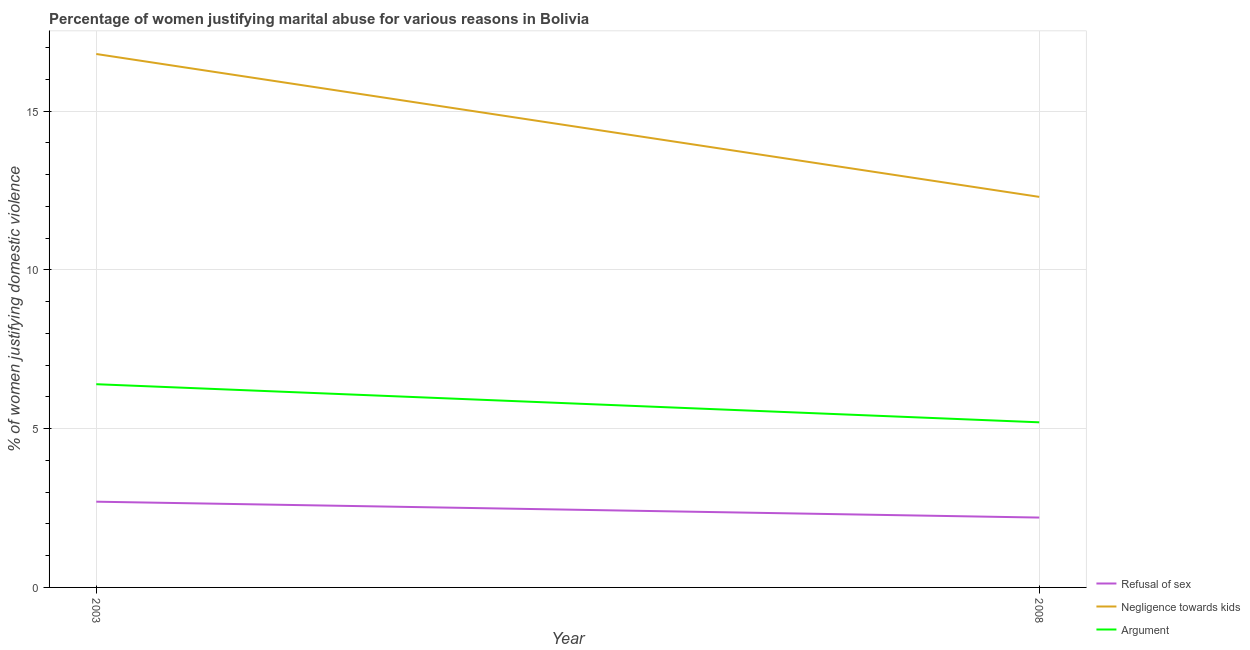Across all years, what is the minimum percentage of women justifying domestic violence due to negligence towards kids?
Give a very brief answer. 12.3. What is the total percentage of women justifying domestic violence due to arguments in the graph?
Your answer should be compact. 11.6. What is the difference between the percentage of women justifying domestic violence due to arguments in 2003 and that in 2008?
Offer a terse response. 1.2. What is the difference between the percentage of women justifying domestic violence due to refusal of sex in 2008 and the percentage of women justifying domestic violence due to negligence towards kids in 2003?
Offer a terse response. -14.6. What is the average percentage of women justifying domestic violence due to arguments per year?
Keep it short and to the point. 5.8. What is the ratio of the percentage of women justifying domestic violence due to refusal of sex in 2003 to that in 2008?
Provide a short and direct response. 1.23. Is the percentage of women justifying domestic violence due to negligence towards kids strictly greater than the percentage of women justifying domestic violence due to arguments over the years?
Offer a very short reply. Yes. How many years are there in the graph?
Your answer should be very brief. 2. What is the difference between two consecutive major ticks on the Y-axis?
Your response must be concise. 5. Where does the legend appear in the graph?
Your answer should be very brief. Bottom right. How are the legend labels stacked?
Give a very brief answer. Vertical. What is the title of the graph?
Give a very brief answer. Percentage of women justifying marital abuse for various reasons in Bolivia. Does "Refusal of sex" appear as one of the legend labels in the graph?
Your response must be concise. Yes. What is the label or title of the Y-axis?
Ensure brevity in your answer.  % of women justifying domestic violence. What is the % of women justifying domestic violence of Negligence towards kids in 2003?
Provide a succinct answer. 16.8. What is the % of women justifying domestic violence in Argument in 2003?
Give a very brief answer. 6.4. What is the % of women justifying domestic violence of Refusal of sex in 2008?
Ensure brevity in your answer.  2.2. What is the % of women justifying domestic violence in Argument in 2008?
Offer a terse response. 5.2. Across all years, what is the maximum % of women justifying domestic violence in Argument?
Provide a succinct answer. 6.4. What is the total % of women justifying domestic violence of Refusal of sex in the graph?
Make the answer very short. 4.9. What is the total % of women justifying domestic violence in Negligence towards kids in the graph?
Your answer should be very brief. 29.1. What is the difference between the % of women justifying domestic violence of Refusal of sex in 2003 and that in 2008?
Offer a very short reply. 0.5. What is the difference between the % of women justifying domestic violence of Negligence towards kids in 2003 and that in 2008?
Offer a terse response. 4.5. What is the difference between the % of women justifying domestic violence in Refusal of sex in 2003 and the % of women justifying domestic violence in Argument in 2008?
Ensure brevity in your answer.  -2.5. What is the difference between the % of women justifying domestic violence in Negligence towards kids in 2003 and the % of women justifying domestic violence in Argument in 2008?
Your answer should be very brief. 11.6. What is the average % of women justifying domestic violence in Refusal of sex per year?
Give a very brief answer. 2.45. What is the average % of women justifying domestic violence of Negligence towards kids per year?
Ensure brevity in your answer.  14.55. What is the average % of women justifying domestic violence in Argument per year?
Make the answer very short. 5.8. In the year 2003, what is the difference between the % of women justifying domestic violence in Refusal of sex and % of women justifying domestic violence in Negligence towards kids?
Make the answer very short. -14.1. In the year 2008, what is the difference between the % of women justifying domestic violence in Refusal of sex and % of women justifying domestic violence in Argument?
Provide a succinct answer. -3. In the year 2008, what is the difference between the % of women justifying domestic violence in Negligence towards kids and % of women justifying domestic violence in Argument?
Give a very brief answer. 7.1. What is the ratio of the % of women justifying domestic violence of Refusal of sex in 2003 to that in 2008?
Keep it short and to the point. 1.23. What is the ratio of the % of women justifying domestic violence of Negligence towards kids in 2003 to that in 2008?
Ensure brevity in your answer.  1.37. What is the ratio of the % of women justifying domestic violence in Argument in 2003 to that in 2008?
Keep it short and to the point. 1.23. What is the difference between the highest and the second highest % of women justifying domestic violence in Refusal of sex?
Offer a terse response. 0.5. What is the difference between the highest and the second highest % of women justifying domestic violence in Argument?
Your answer should be compact. 1.2. What is the difference between the highest and the lowest % of women justifying domestic violence of Argument?
Offer a very short reply. 1.2. 